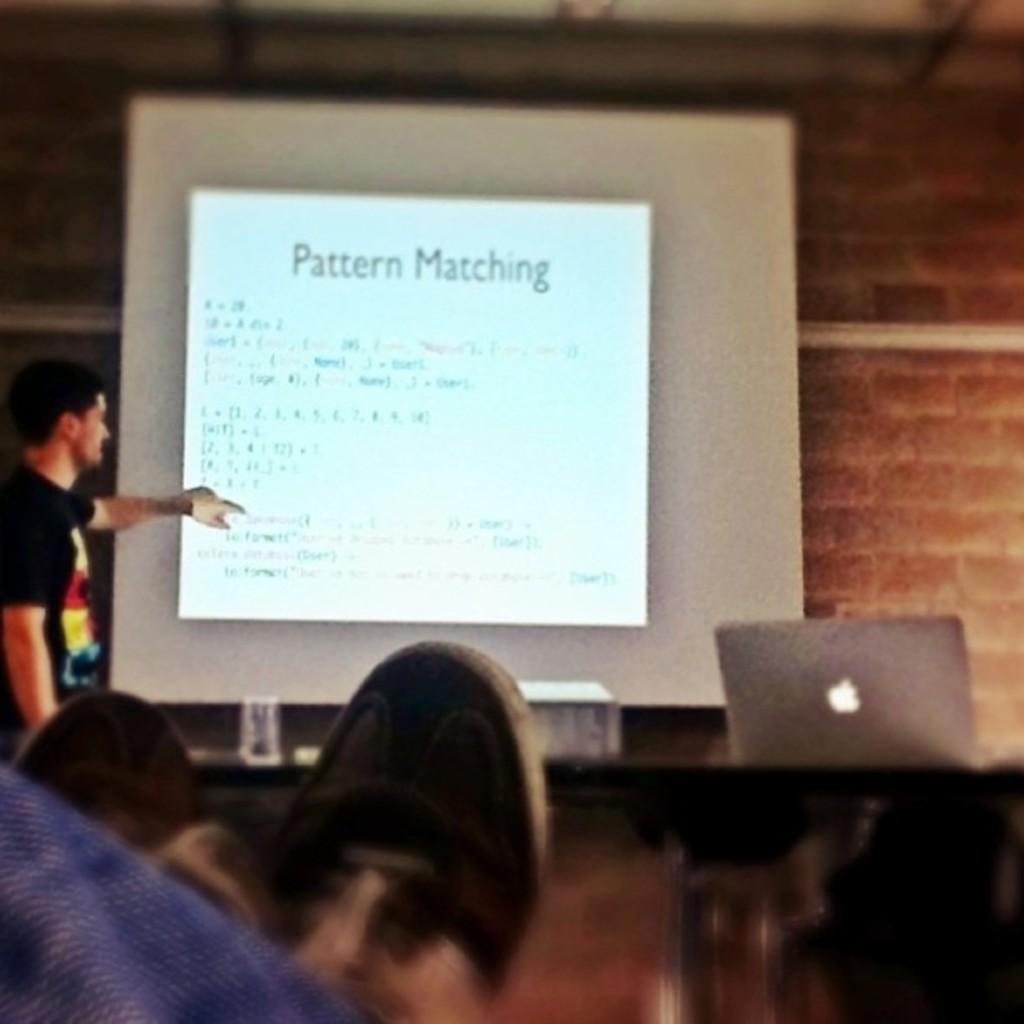How would you summarize this image in a sentence or two? In this image we can see a person at the screen. At the bottom of the image we can see laptop and human legs. In the background there is a wall. 